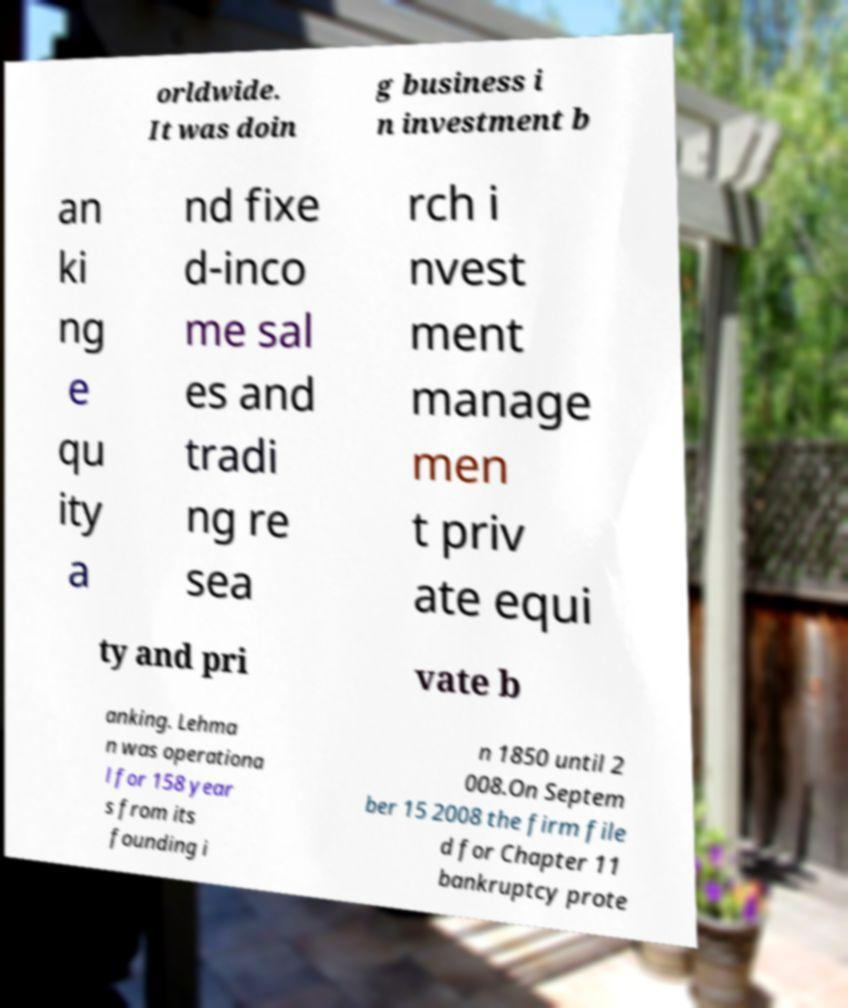Please identify and transcribe the text found in this image. orldwide. It was doin g business i n investment b an ki ng e qu ity a nd fixe d-inco me sal es and tradi ng re sea rch i nvest ment manage men t priv ate equi ty and pri vate b anking. Lehma n was operationa l for 158 year s from its founding i n 1850 until 2 008.On Septem ber 15 2008 the firm file d for Chapter 11 bankruptcy prote 